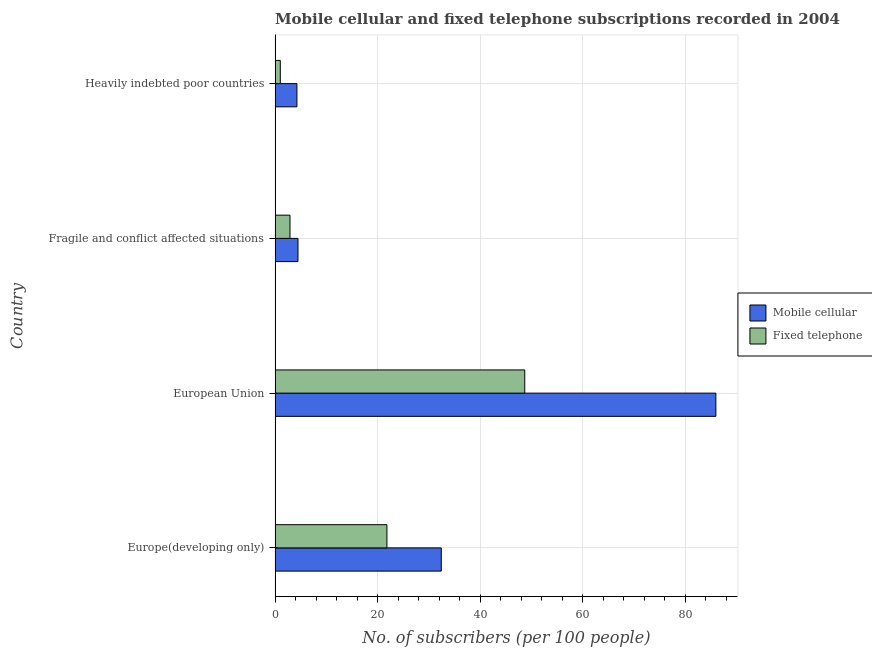How many groups of bars are there?
Make the answer very short. 4. How many bars are there on the 2nd tick from the top?
Keep it short and to the point. 2. What is the label of the 1st group of bars from the top?
Ensure brevity in your answer.  Heavily indebted poor countries. What is the number of fixed telephone subscribers in Fragile and conflict affected situations?
Give a very brief answer. 2.91. Across all countries, what is the maximum number of mobile cellular subscribers?
Your answer should be very brief. 85.94. Across all countries, what is the minimum number of mobile cellular subscribers?
Your answer should be very brief. 4.26. In which country was the number of fixed telephone subscribers maximum?
Your answer should be very brief. European Union. In which country was the number of fixed telephone subscribers minimum?
Offer a terse response. Heavily indebted poor countries. What is the total number of fixed telephone subscribers in the graph?
Give a very brief answer. 74.4. What is the difference between the number of mobile cellular subscribers in Europe(developing only) and that in European Union?
Provide a succinct answer. -53.54. What is the difference between the number of fixed telephone subscribers in Fragile and conflict affected situations and the number of mobile cellular subscribers in European Union?
Provide a short and direct response. -83.03. What is the average number of mobile cellular subscribers per country?
Provide a short and direct response. 31.77. What is the difference between the number of fixed telephone subscribers and number of mobile cellular subscribers in Europe(developing only)?
Provide a short and direct response. -10.6. In how many countries, is the number of fixed telephone subscribers greater than 4 ?
Keep it short and to the point. 2. What is the ratio of the number of fixed telephone subscribers in Europe(developing only) to that in European Union?
Offer a terse response. 0.45. What is the difference between the highest and the second highest number of fixed telephone subscribers?
Give a very brief answer. 26.87. What is the difference between the highest and the lowest number of mobile cellular subscribers?
Offer a terse response. 81.68. Is the sum of the number of fixed telephone subscribers in Europe(developing only) and Fragile and conflict affected situations greater than the maximum number of mobile cellular subscribers across all countries?
Your answer should be compact. No. What does the 2nd bar from the top in Heavily indebted poor countries represents?
Your response must be concise. Mobile cellular. What does the 2nd bar from the bottom in Europe(developing only) represents?
Provide a short and direct response. Fixed telephone. Are all the bars in the graph horizontal?
Ensure brevity in your answer.  Yes. Are the values on the major ticks of X-axis written in scientific E-notation?
Make the answer very short. No. Does the graph contain any zero values?
Offer a very short reply. No. How many legend labels are there?
Make the answer very short. 2. How are the legend labels stacked?
Ensure brevity in your answer.  Vertical. What is the title of the graph?
Keep it short and to the point. Mobile cellular and fixed telephone subscriptions recorded in 2004. What is the label or title of the X-axis?
Offer a very short reply. No. of subscribers (per 100 people). What is the No. of subscribers (per 100 people) of Mobile cellular in Europe(developing only)?
Offer a very short reply. 32.4. What is the No. of subscribers (per 100 people) of Fixed telephone in Europe(developing only)?
Your response must be concise. 21.81. What is the No. of subscribers (per 100 people) of Mobile cellular in European Union?
Provide a short and direct response. 85.94. What is the No. of subscribers (per 100 people) of Fixed telephone in European Union?
Provide a short and direct response. 48.68. What is the No. of subscribers (per 100 people) of Mobile cellular in Fragile and conflict affected situations?
Your answer should be very brief. 4.46. What is the No. of subscribers (per 100 people) in Fixed telephone in Fragile and conflict affected situations?
Your answer should be compact. 2.91. What is the No. of subscribers (per 100 people) of Mobile cellular in Heavily indebted poor countries?
Give a very brief answer. 4.26. What is the No. of subscribers (per 100 people) of Fixed telephone in Heavily indebted poor countries?
Ensure brevity in your answer.  1.02. Across all countries, what is the maximum No. of subscribers (per 100 people) in Mobile cellular?
Provide a succinct answer. 85.94. Across all countries, what is the maximum No. of subscribers (per 100 people) of Fixed telephone?
Make the answer very short. 48.68. Across all countries, what is the minimum No. of subscribers (per 100 people) of Mobile cellular?
Your answer should be very brief. 4.26. Across all countries, what is the minimum No. of subscribers (per 100 people) in Fixed telephone?
Keep it short and to the point. 1.02. What is the total No. of subscribers (per 100 people) of Mobile cellular in the graph?
Keep it short and to the point. 127.07. What is the total No. of subscribers (per 100 people) in Fixed telephone in the graph?
Ensure brevity in your answer.  74.41. What is the difference between the No. of subscribers (per 100 people) of Mobile cellular in Europe(developing only) and that in European Union?
Offer a terse response. -53.54. What is the difference between the No. of subscribers (per 100 people) of Fixed telephone in Europe(developing only) and that in European Union?
Offer a very short reply. -26.87. What is the difference between the No. of subscribers (per 100 people) in Mobile cellular in Europe(developing only) and that in Fragile and conflict affected situations?
Your answer should be very brief. 27.94. What is the difference between the No. of subscribers (per 100 people) in Fixed telephone in Europe(developing only) and that in Fragile and conflict affected situations?
Provide a short and direct response. 18.9. What is the difference between the No. of subscribers (per 100 people) of Mobile cellular in Europe(developing only) and that in Heavily indebted poor countries?
Provide a succinct answer. 28.15. What is the difference between the No. of subscribers (per 100 people) in Fixed telephone in Europe(developing only) and that in Heavily indebted poor countries?
Make the answer very short. 20.79. What is the difference between the No. of subscribers (per 100 people) of Mobile cellular in European Union and that in Fragile and conflict affected situations?
Provide a short and direct response. 81.48. What is the difference between the No. of subscribers (per 100 people) of Fixed telephone in European Union and that in Fragile and conflict affected situations?
Offer a very short reply. 45.77. What is the difference between the No. of subscribers (per 100 people) of Mobile cellular in European Union and that in Heavily indebted poor countries?
Offer a terse response. 81.68. What is the difference between the No. of subscribers (per 100 people) of Fixed telephone in European Union and that in Heavily indebted poor countries?
Offer a very short reply. 47.66. What is the difference between the No. of subscribers (per 100 people) of Mobile cellular in Fragile and conflict affected situations and that in Heavily indebted poor countries?
Your response must be concise. 0.21. What is the difference between the No. of subscribers (per 100 people) in Fixed telephone in Fragile and conflict affected situations and that in Heavily indebted poor countries?
Offer a very short reply. 1.89. What is the difference between the No. of subscribers (per 100 people) of Mobile cellular in Europe(developing only) and the No. of subscribers (per 100 people) of Fixed telephone in European Union?
Keep it short and to the point. -16.27. What is the difference between the No. of subscribers (per 100 people) of Mobile cellular in Europe(developing only) and the No. of subscribers (per 100 people) of Fixed telephone in Fragile and conflict affected situations?
Make the answer very short. 29.5. What is the difference between the No. of subscribers (per 100 people) of Mobile cellular in Europe(developing only) and the No. of subscribers (per 100 people) of Fixed telephone in Heavily indebted poor countries?
Your response must be concise. 31.39. What is the difference between the No. of subscribers (per 100 people) of Mobile cellular in European Union and the No. of subscribers (per 100 people) of Fixed telephone in Fragile and conflict affected situations?
Make the answer very short. 83.03. What is the difference between the No. of subscribers (per 100 people) of Mobile cellular in European Union and the No. of subscribers (per 100 people) of Fixed telephone in Heavily indebted poor countries?
Your answer should be very brief. 84.92. What is the difference between the No. of subscribers (per 100 people) in Mobile cellular in Fragile and conflict affected situations and the No. of subscribers (per 100 people) in Fixed telephone in Heavily indebted poor countries?
Your response must be concise. 3.45. What is the average No. of subscribers (per 100 people) of Mobile cellular per country?
Provide a short and direct response. 31.77. What is the average No. of subscribers (per 100 people) of Fixed telephone per country?
Provide a succinct answer. 18.6. What is the difference between the No. of subscribers (per 100 people) in Mobile cellular and No. of subscribers (per 100 people) in Fixed telephone in Europe(developing only)?
Provide a short and direct response. 10.6. What is the difference between the No. of subscribers (per 100 people) in Mobile cellular and No. of subscribers (per 100 people) in Fixed telephone in European Union?
Ensure brevity in your answer.  37.26. What is the difference between the No. of subscribers (per 100 people) in Mobile cellular and No. of subscribers (per 100 people) in Fixed telephone in Fragile and conflict affected situations?
Give a very brief answer. 1.56. What is the difference between the No. of subscribers (per 100 people) of Mobile cellular and No. of subscribers (per 100 people) of Fixed telephone in Heavily indebted poor countries?
Ensure brevity in your answer.  3.24. What is the ratio of the No. of subscribers (per 100 people) in Mobile cellular in Europe(developing only) to that in European Union?
Your answer should be compact. 0.38. What is the ratio of the No. of subscribers (per 100 people) in Fixed telephone in Europe(developing only) to that in European Union?
Your answer should be compact. 0.45. What is the ratio of the No. of subscribers (per 100 people) of Mobile cellular in Europe(developing only) to that in Fragile and conflict affected situations?
Give a very brief answer. 7.26. What is the ratio of the No. of subscribers (per 100 people) of Fixed telephone in Europe(developing only) to that in Fragile and conflict affected situations?
Your response must be concise. 7.5. What is the ratio of the No. of subscribers (per 100 people) of Mobile cellular in Europe(developing only) to that in Heavily indebted poor countries?
Keep it short and to the point. 7.61. What is the ratio of the No. of subscribers (per 100 people) in Fixed telephone in Europe(developing only) to that in Heavily indebted poor countries?
Keep it short and to the point. 21.47. What is the ratio of the No. of subscribers (per 100 people) of Mobile cellular in European Union to that in Fragile and conflict affected situations?
Your answer should be compact. 19.25. What is the ratio of the No. of subscribers (per 100 people) of Fixed telephone in European Union to that in Fragile and conflict affected situations?
Offer a terse response. 16.75. What is the ratio of the No. of subscribers (per 100 people) in Mobile cellular in European Union to that in Heavily indebted poor countries?
Make the answer very short. 20.18. What is the ratio of the No. of subscribers (per 100 people) in Fixed telephone in European Union to that in Heavily indebted poor countries?
Your answer should be compact. 47.93. What is the ratio of the No. of subscribers (per 100 people) of Mobile cellular in Fragile and conflict affected situations to that in Heavily indebted poor countries?
Your answer should be compact. 1.05. What is the ratio of the No. of subscribers (per 100 people) in Fixed telephone in Fragile and conflict affected situations to that in Heavily indebted poor countries?
Make the answer very short. 2.86. What is the difference between the highest and the second highest No. of subscribers (per 100 people) of Mobile cellular?
Give a very brief answer. 53.54. What is the difference between the highest and the second highest No. of subscribers (per 100 people) in Fixed telephone?
Ensure brevity in your answer.  26.87. What is the difference between the highest and the lowest No. of subscribers (per 100 people) of Mobile cellular?
Provide a succinct answer. 81.68. What is the difference between the highest and the lowest No. of subscribers (per 100 people) in Fixed telephone?
Offer a terse response. 47.66. 